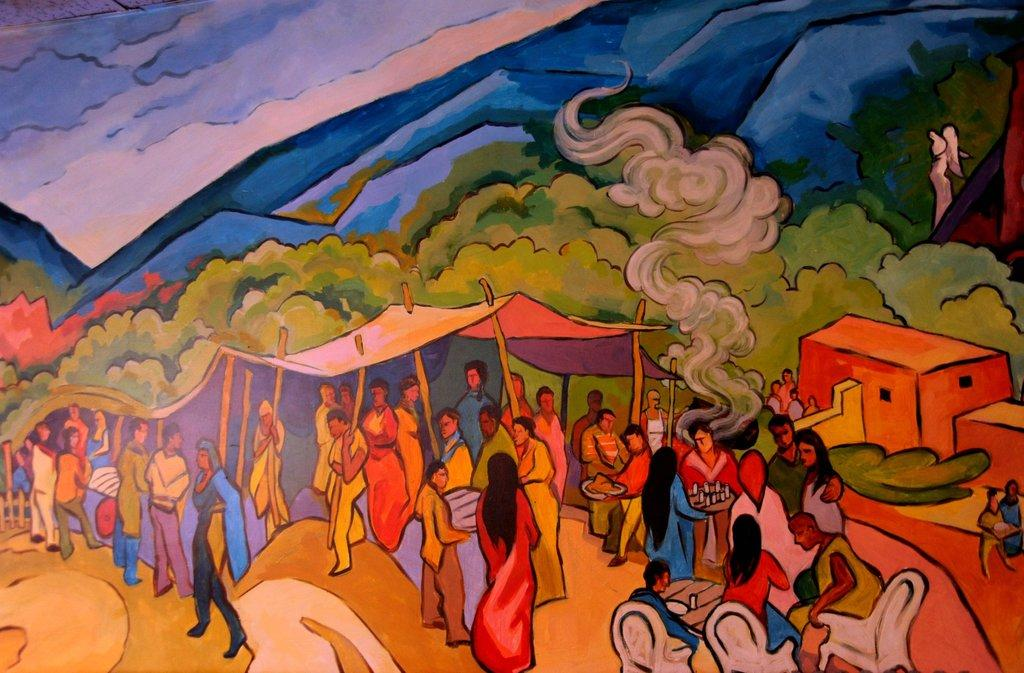How many people are in the image? There is a group of people standing in the image. What type of furniture is present in the image? There are chairs and a table in the image. What type of building is visible in the image? There is a house in the image. What type of temporary shelter is visible in the image? There is a tent with poles in the image. What is the source of the smoke in the image? The source of the smoke in the image is not mentioned, but it is visible. What type of natural landscape is visible in the image? There are hills and trees in the image. What part of the natural environment is visible in the image? The sky is visible in the image. What type of plough is being used to cultivate the land in the image? There is no plough present in the image; it features a group of people, chairs, a table, a house, a tent, smoke, hills, trees, and the sky. 